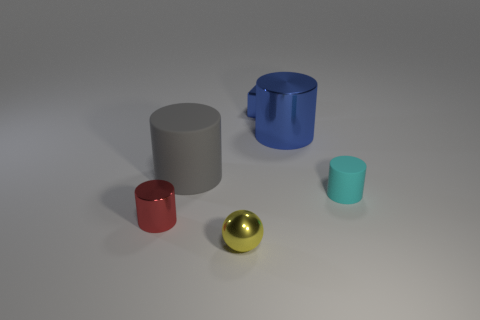Add 2 large cyan rubber objects. How many objects exist? 8 Subtract all gray cylinders. How many cylinders are left? 3 Subtract 1 cylinders. How many cylinders are left? 3 Subtract all balls. How many objects are left? 5 Subtract all brown cylinders. Subtract all purple spheres. How many cylinders are left? 4 Subtract all red cylinders. How many green cubes are left? 0 Subtract all large brown shiny cylinders. Subtract all large metal cylinders. How many objects are left? 5 Add 4 big metal objects. How many big metal objects are left? 5 Add 6 large blue shiny objects. How many large blue shiny objects exist? 7 Subtract 0 purple cylinders. How many objects are left? 6 